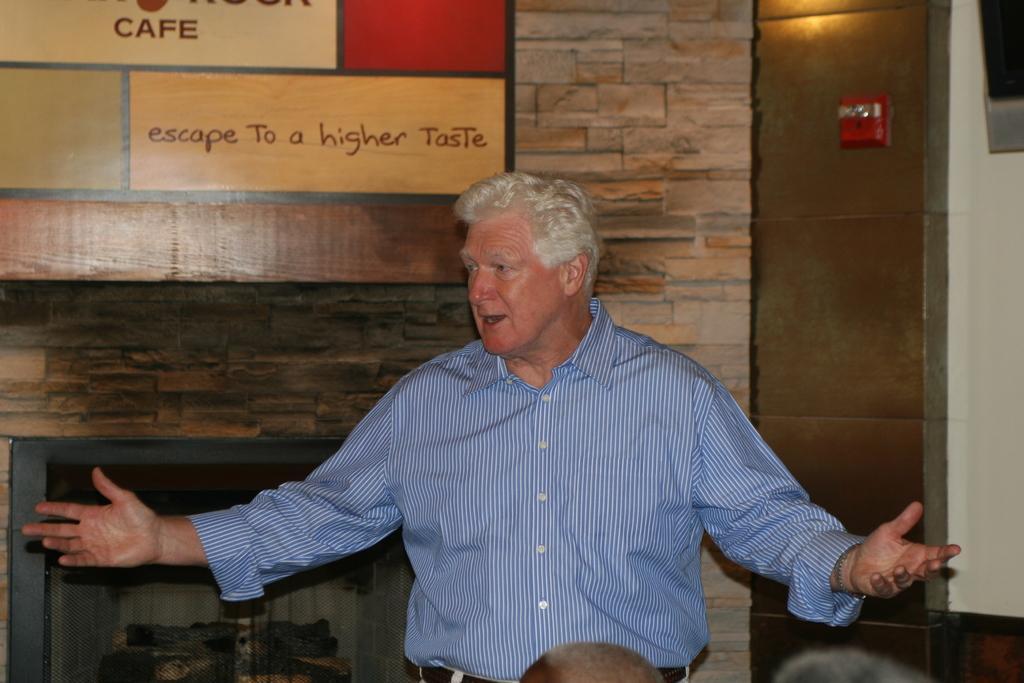In one or two sentences, can you explain what this image depicts? At the bottom there are heads of some people. In the center of the picture there is a person standing and talking. At the top left there is a board. In the background there is a wall. On the right it is well. On the left there is a fireplace. 